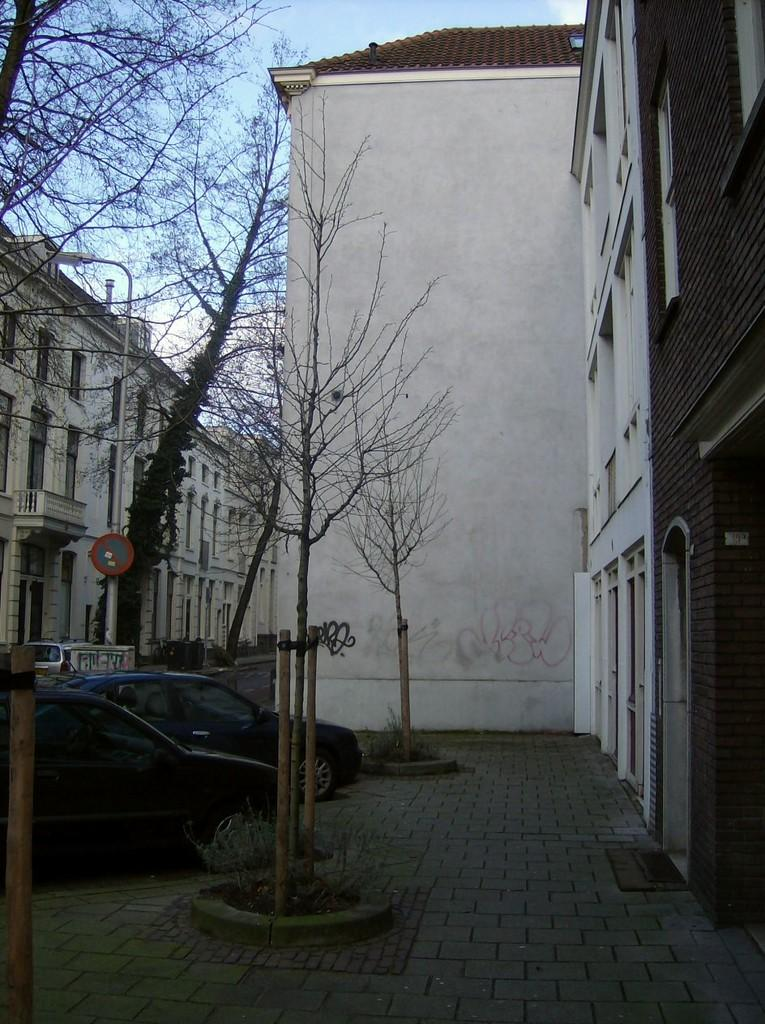What type of structures can be seen in the image? There are buildings in the image. What is the surface beneath the buildings and vehicles? There is a pavement in the image. What type of vegetation is present in the image? There are trees in the image. What type of transportation can be seen in the image? There are vehicles in the image. What is attached to the pole in the image? There is a pole with a sign board in the image. What is used to illuminate the area at night? There is a street light in the image. What is the interest rate on the loan mentioned on the sign board in the image? There is no mention of a loan or interest rate on the sign board in the image. What time of day is it in the image, given that it is morning? The time of day cannot be determined from the image, and there is no indication that it is morning. 